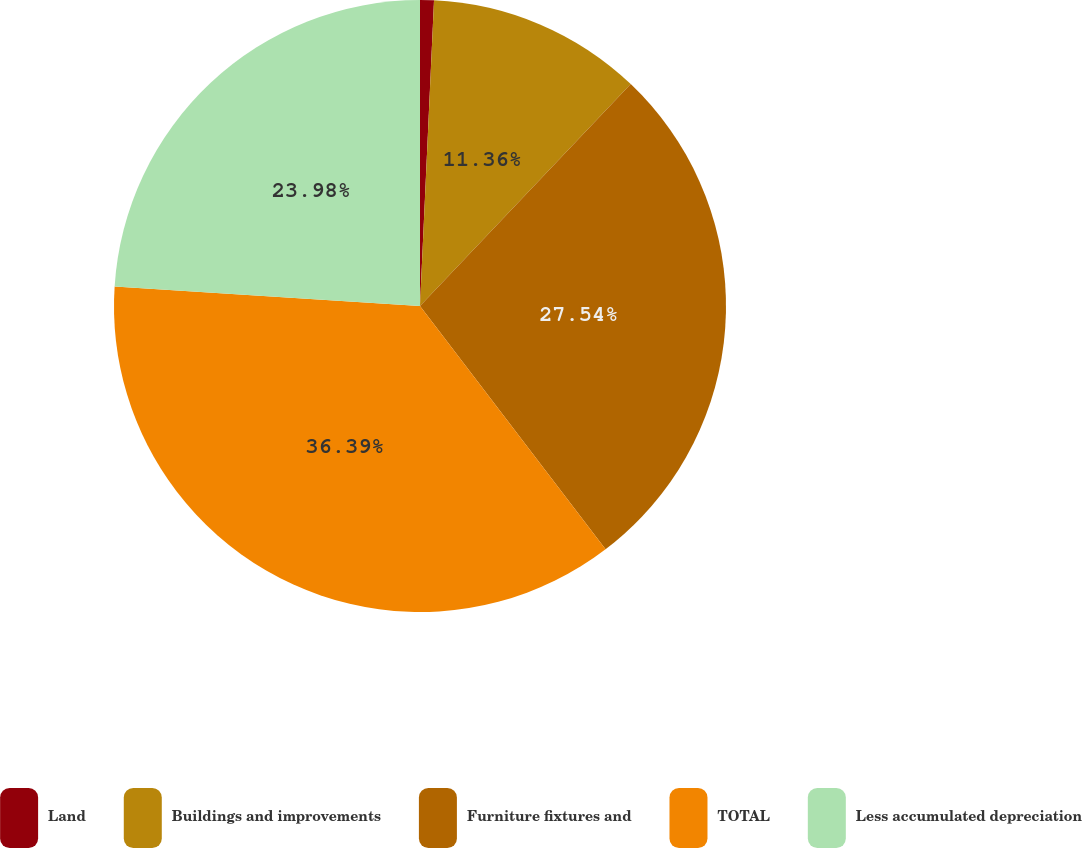Convert chart. <chart><loc_0><loc_0><loc_500><loc_500><pie_chart><fcel>Land<fcel>Buildings and improvements<fcel>Furniture fixtures and<fcel>TOTAL<fcel>Less accumulated depreciation<nl><fcel>0.73%<fcel>11.36%<fcel>27.54%<fcel>36.39%<fcel>23.98%<nl></chart> 